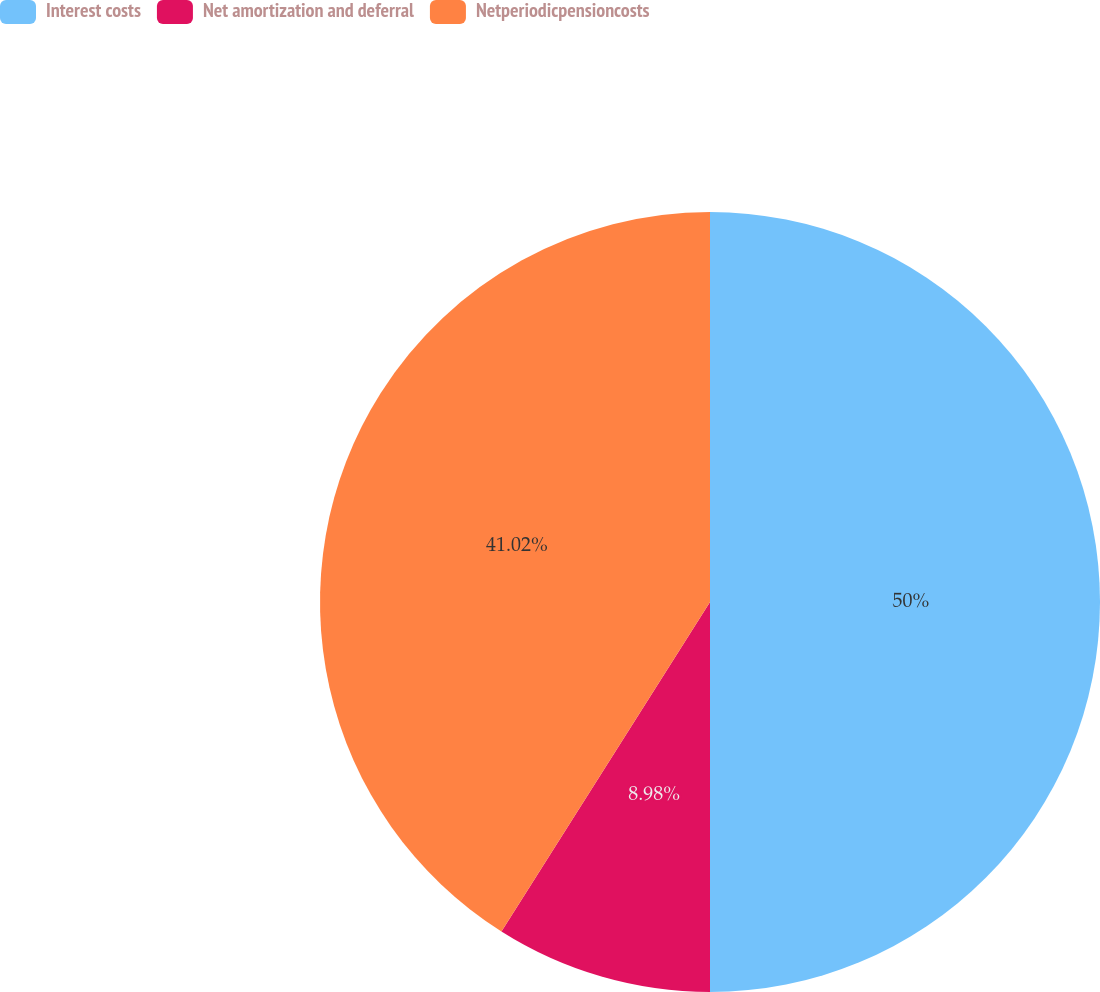Convert chart to OTSL. <chart><loc_0><loc_0><loc_500><loc_500><pie_chart><fcel>Interest costs<fcel>Net amortization and deferral<fcel>Netperiodicpensioncosts<nl><fcel>50.0%<fcel>8.98%<fcel>41.02%<nl></chart> 